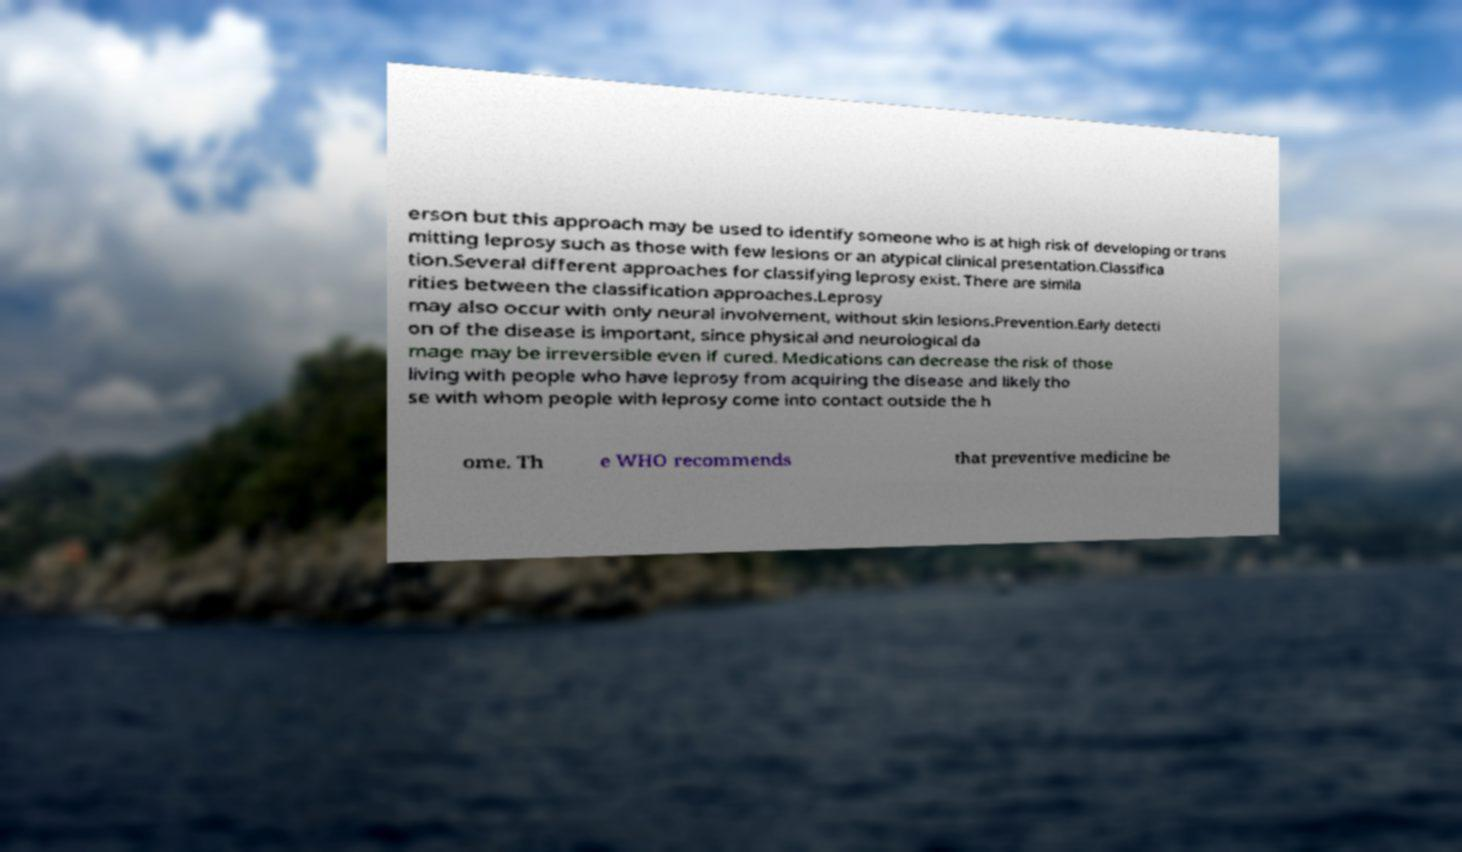Could you assist in decoding the text presented in this image and type it out clearly? erson but this approach may be used to identify someone who is at high risk of developing or trans mitting leprosy such as those with few lesions or an atypical clinical presentation.Classifica tion.Several different approaches for classifying leprosy exist. There are simila rities between the classification approaches.Leprosy may also occur with only neural involvement, without skin lesions.Prevention.Early detecti on of the disease is important, since physical and neurological da mage may be irreversible even if cured. Medications can decrease the risk of those living with people who have leprosy from acquiring the disease and likely tho se with whom people with leprosy come into contact outside the h ome. Th e WHO recommends that preventive medicine be 